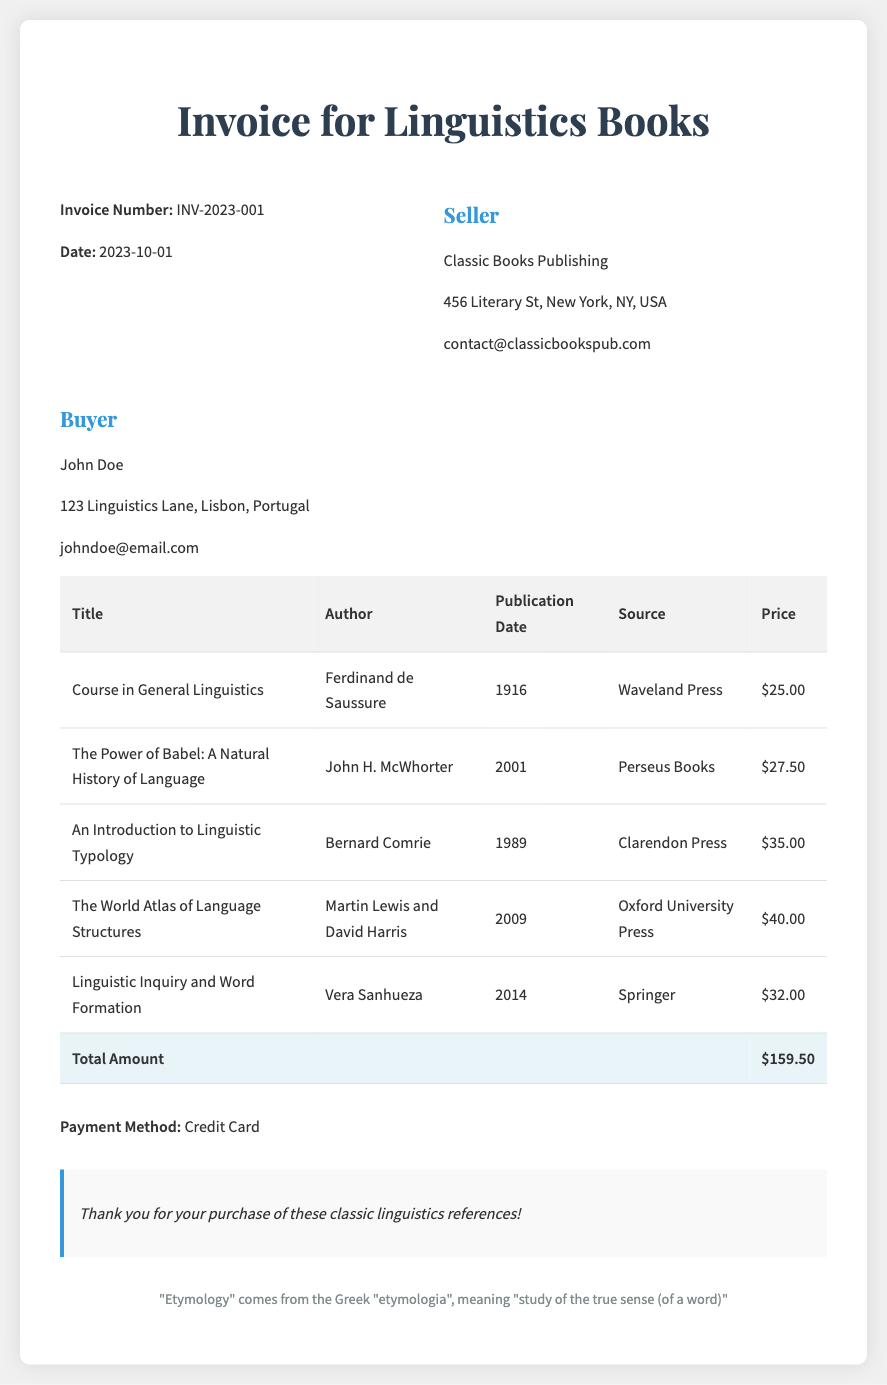What is the invoice number? The invoice number is stated prominently in the document as a unique identifier for the transaction.
Answer: INV-2023-001 Who is the author of "Course in General Linguistics"? The author is listed alongside the title of the book as part of the book details in the invoice.
Answer: Ferdinand de Saussure What is the publication date of "The World Atlas of Language Structures"? The publication date is provided in the document under the specific book title, reflecting its release year.
Answer: 2009 What is the total amount due? The total amount reflects the sum of all prices listed for the books in the invoice and is clearly indicated at the bottom.
Answer: $159.50 Who is the seller of the books? The seller's information is clearly stated at the top of the invoice, representing the entity selling the books.
Answer: Classic Books Publishing Which payment method was used for this transaction? The payment method is mentioned directly in the invoice, indicating how the buyer completed the purchase.
Answer: Credit Card What source published "Linguistic Inquiry and Word Formation"? The source refers to the publishing company and is noted as part of the complete book information.
Answer: Springer What year was "An Introduction to Linguistic Typology" published? The publication year is attributed to the book title, showing when it was made available to the public.
Answer: 1989 Who is the purchaser mentioned in the document? The purchaser's details are noted in the "Buyer" section, showing who made the purchase.
Answer: John Doe 